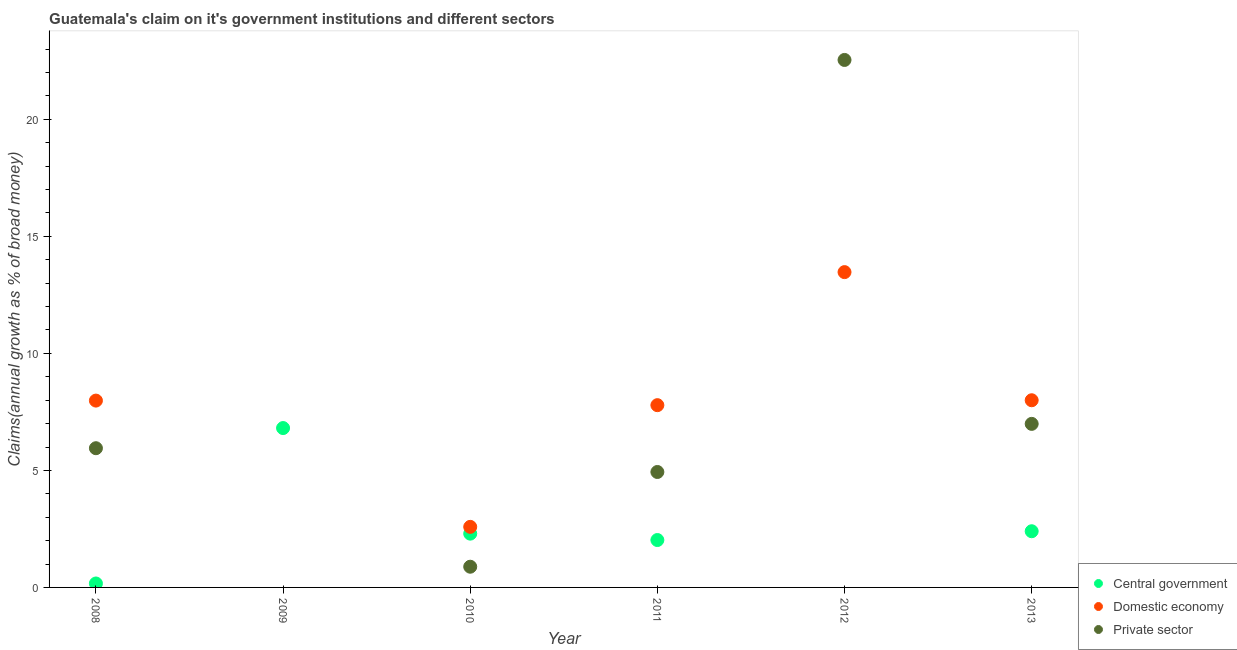Is the number of dotlines equal to the number of legend labels?
Your response must be concise. No. Across all years, what is the maximum percentage of claim on the central government?
Ensure brevity in your answer.  6.81. Across all years, what is the minimum percentage of claim on the private sector?
Make the answer very short. 0. In which year was the percentage of claim on the private sector maximum?
Your answer should be very brief. 2012. What is the total percentage of claim on the central government in the graph?
Your response must be concise. 13.7. What is the difference between the percentage of claim on the private sector in 2008 and that in 2010?
Make the answer very short. 5.06. What is the difference between the percentage of claim on the private sector in 2012 and the percentage of claim on the central government in 2009?
Keep it short and to the point. 15.73. What is the average percentage of claim on the private sector per year?
Ensure brevity in your answer.  6.88. In the year 2010, what is the difference between the percentage of claim on the central government and percentage of claim on the domestic economy?
Keep it short and to the point. -0.29. What is the ratio of the percentage of claim on the private sector in 2010 to that in 2011?
Give a very brief answer. 0.18. What is the difference between the highest and the second highest percentage of claim on the private sector?
Offer a very short reply. 15.55. What is the difference between the highest and the lowest percentage of claim on the domestic economy?
Offer a terse response. 13.47. Is the percentage of claim on the private sector strictly greater than the percentage of claim on the central government over the years?
Your answer should be compact. No. How many dotlines are there?
Provide a short and direct response. 3. How many years are there in the graph?
Offer a terse response. 6. What is the difference between two consecutive major ticks on the Y-axis?
Provide a succinct answer. 5. Are the values on the major ticks of Y-axis written in scientific E-notation?
Your answer should be compact. No. Where does the legend appear in the graph?
Give a very brief answer. Bottom right. How are the legend labels stacked?
Make the answer very short. Vertical. What is the title of the graph?
Keep it short and to the point. Guatemala's claim on it's government institutions and different sectors. What is the label or title of the Y-axis?
Provide a succinct answer. Claims(annual growth as % of broad money). What is the Claims(annual growth as % of broad money) in Central government in 2008?
Your answer should be compact. 0.17. What is the Claims(annual growth as % of broad money) in Domestic economy in 2008?
Provide a short and direct response. 7.98. What is the Claims(annual growth as % of broad money) of Private sector in 2008?
Give a very brief answer. 5.95. What is the Claims(annual growth as % of broad money) in Central government in 2009?
Your response must be concise. 6.81. What is the Claims(annual growth as % of broad money) of Domestic economy in 2009?
Your answer should be compact. 0. What is the Claims(annual growth as % of broad money) in Central government in 2010?
Your answer should be very brief. 2.3. What is the Claims(annual growth as % of broad money) of Domestic economy in 2010?
Keep it short and to the point. 2.59. What is the Claims(annual growth as % of broad money) in Private sector in 2010?
Your answer should be very brief. 0.88. What is the Claims(annual growth as % of broad money) of Central government in 2011?
Your response must be concise. 2.03. What is the Claims(annual growth as % of broad money) of Domestic economy in 2011?
Ensure brevity in your answer.  7.79. What is the Claims(annual growth as % of broad money) in Private sector in 2011?
Provide a succinct answer. 4.93. What is the Claims(annual growth as % of broad money) of Domestic economy in 2012?
Give a very brief answer. 13.47. What is the Claims(annual growth as % of broad money) in Private sector in 2012?
Your response must be concise. 22.54. What is the Claims(annual growth as % of broad money) in Central government in 2013?
Keep it short and to the point. 2.4. What is the Claims(annual growth as % of broad money) of Domestic economy in 2013?
Offer a very short reply. 8. What is the Claims(annual growth as % of broad money) of Private sector in 2013?
Your response must be concise. 6.99. Across all years, what is the maximum Claims(annual growth as % of broad money) in Central government?
Offer a very short reply. 6.81. Across all years, what is the maximum Claims(annual growth as % of broad money) of Domestic economy?
Ensure brevity in your answer.  13.47. Across all years, what is the maximum Claims(annual growth as % of broad money) in Private sector?
Your answer should be compact. 22.54. Across all years, what is the minimum Claims(annual growth as % of broad money) in Domestic economy?
Keep it short and to the point. 0. Across all years, what is the minimum Claims(annual growth as % of broad money) of Private sector?
Ensure brevity in your answer.  0. What is the total Claims(annual growth as % of broad money) of Central government in the graph?
Offer a very short reply. 13.7. What is the total Claims(annual growth as % of broad money) of Domestic economy in the graph?
Your answer should be compact. 39.83. What is the total Claims(annual growth as % of broad money) of Private sector in the graph?
Your answer should be very brief. 41.29. What is the difference between the Claims(annual growth as % of broad money) of Central government in 2008 and that in 2009?
Offer a terse response. -6.64. What is the difference between the Claims(annual growth as % of broad money) of Central government in 2008 and that in 2010?
Offer a very short reply. -2.13. What is the difference between the Claims(annual growth as % of broad money) in Domestic economy in 2008 and that in 2010?
Your answer should be compact. 5.39. What is the difference between the Claims(annual growth as % of broad money) of Private sector in 2008 and that in 2010?
Your answer should be compact. 5.06. What is the difference between the Claims(annual growth as % of broad money) of Central government in 2008 and that in 2011?
Offer a terse response. -1.86. What is the difference between the Claims(annual growth as % of broad money) in Domestic economy in 2008 and that in 2011?
Make the answer very short. 0.2. What is the difference between the Claims(annual growth as % of broad money) in Private sector in 2008 and that in 2011?
Offer a terse response. 1.02. What is the difference between the Claims(annual growth as % of broad money) of Domestic economy in 2008 and that in 2012?
Keep it short and to the point. -5.49. What is the difference between the Claims(annual growth as % of broad money) of Private sector in 2008 and that in 2012?
Your answer should be compact. -16.59. What is the difference between the Claims(annual growth as % of broad money) in Central government in 2008 and that in 2013?
Offer a terse response. -2.23. What is the difference between the Claims(annual growth as % of broad money) in Domestic economy in 2008 and that in 2013?
Your answer should be compact. -0.01. What is the difference between the Claims(annual growth as % of broad money) of Private sector in 2008 and that in 2013?
Make the answer very short. -1.04. What is the difference between the Claims(annual growth as % of broad money) of Central government in 2009 and that in 2010?
Ensure brevity in your answer.  4.51. What is the difference between the Claims(annual growth as % of broad money) of Central government in 2009 and that in 2011?
Provide a short and direct response. 4.78. What is the difference between the Claims(annual growth as % of broad money) of Central government in 2009 and that in 2013?
Ensure brevity in your answer.  4.41. What is the difference between the Claims(annual growth as % of broad money) of Central government in 2010 and that in 2011?
Your answer should be very brief. 0.27. What is the difference between the Claims(annual growth as % of broad money) in Domestic economy in 2010 and that in 2011?
Make the answer very short. -5.2. What is the difference between the Claims(annual growth as % of broad money) in Private sector in 2010 and that in 2011?
Give a very brief answer. -4.05. What is the difference between the Claims(annual growth as % of broad money) of Domestic economy in 2010 and that in 2012?
Ensure brevity in your answer.  -10.88. What is the difference between the Claims(annual growth as % of broad money) in Private sector in 2010 and that in 2012?
Give a very brief answer. -21.65. What is the difference between the Claims(annual growth as % of broad money) of Central government in 2010 and that in 2013?
Provide a succinct answer. -0.1. What is the difference between the Claims(annual growth as % of broad money) of Domestic economy in 2010 and that in 2013?
Provide a short and direct response. -5.41. What is the difference between the Claims(annual growth as % of broad money) in Private sector in 2010 and that in 2013?
Your response must be concise. -6.1. What is the difference between the Claims(annual growth as % of broad money) in Domestic economy in 2011 and that in 2012?
Your answer should be very brief. -5.68. What is the difference between the Claims(annual growth as % of broad money) of Private sector in 2011 and that in 2012?
Your answer should be compact. -17.61. What is the difference between the Claims(annual growth as % of broad money) in Central government in 2011 and that in 2013?
Provide a short and direct response. -0.38. What is the difference between the Claims(annual growth as % of broad money) of Domestic economy in 2011 and that in 2013?
Keep it short and to the point. -0.21. What is the difference between the Claims(annual growth as % of broad money) of Private sector in 2011 and that in 2013?
Offer a very short reply. -2.06. What is the difference between the Claims(annual growth as % of broad money) of Domestic economy in 2012 and that in 2013?
Provide a short and direct response. 5.47. What is the difference between the Claims(annual growth as % of broad money) in Private sector in 2012 and that in 2013?
Offer a very short reply. 15.55. What is the difference between the Claims(annual growth as % of broad money) in Central government in 2008 and the Claims(annual growth as % of broad money) in Domestic economy in 2010?
Offer a very short reply. -2.42. What is the difference between the Claims(annual growth as % of broad money) in Central government in 2008 and the Claims(annual growth as % of broad money) in Private sector in 2010?
Keep it short and to the point. -0.72. What is the difference between the Claims(annual growth as % of broad money) of Domestic economy in 2008 and the Claims(annual growth as % of broad money) of Private sector in 2010?
Offer a very short reply. 7.1. What is the difference between the Claims(annual growth as % of broad money) of Central government in 2008 and the Claims(annual growth as % of broad money) of Domestic economy in 2011?
Your response must be concise. -7.62. What is the difference between the Claims(annual growth as % of broad money) of Central government in 2008 and the Claims(annual growth as % of broad money) of Private sector in 2011?
Your answer should be compact. -4.76. What is the difference between the Claims(annual growth as % of broad money) of Domestic economy in 2008 and the Claims(annual growth as % of broad money) of Private sector in 2011?
Make the answer very short. 3.05. What is the difference between the Claims(annual growth as % of broad money) of Central government in 2008 and the Claims(annual growth as % of broad money) of Domestic economy in 2012?
Your answer should be compact. -13.3. What is the difference between the Claims(annual growth as % of broad money) in Central government in 2008 and the Claims(annual growth as % of broad money) in Private sector in 2012?
Your answer should be compact. -22.37. What is the difference between the Claims(annual growth as % of broad money) of Domestic economy in 2008 and the Claims(annual growth as % of broad money) of Private sector in 2012?
Your answer should be compact. -14.55. What is the difference between the Claims(annual growth as % of broad money) in Central government in 2008 and the Claims(annual growth as % of broad money) in Domestic economy in 2013?
Your answer should be compact. -7.83. What is the difference between the Claims(annual growth as % of broad money) in Central government in 2008 and the Claims(annual growth as % of broad money) in Private sector in 2013?
Your answer should be very brief. -6.82. What is the difference between the Claims(annual growth as % of broad money) of Domestic economy in 2008 and the Claims(annual growth as % of broad money) of Private sector in 2013?
Offer a very short reply. 0.99. What is the difference between the Claims(annual growth as % of broad money) in Central government in 2009 and the Claims(annual growth as % of broad money) in Domestic economy in 2010?
Ensure brevity in your answer.  4.22. What is the difference between the Claims(annual growth as % of broad money) of Central government in 2009 and the Claims(annual growth as % of broad money) of Private sector in 2010?
Offer a very short reply. 5.92. What is the difference between the Claims(annual growth as % of broad money) in Central government in 2009 and the Claims(annual growth as % of broad money) in Domestic economy in 2011?
Your response must be concise. -0.98. What is the difference between the Claims(annual growth as % of broad money) of Central government in 2009 and the Claims(annual growth as % of broad money) of Private sector in 2011?
Provide a succinct answer. 1.88. What is the difference between the Claims(annual growth as % of broad money) of Central government in 2009 and the Claims(annual growth as % of broad money) of Domestic economy in 2012?
Provide a succinct answer. -6.66. What is the difference between the Claims(annual growth as % of broad money) of Central government in 2009 and the Claims(annual growth as % of broad money) of Private sector in 2012?
Ensure brevity in your answer.  -15.73. What is the difference between the Claims(annual growth as % of broad money) in Central government in 2009 and the Claims(annual growth as % of broad money) in Domestic economy in 2013?
Provide a succinct answer. -1.19. What is the difference between the Claims(annual growth as % of broad money) of Central government in 2009 and the Claims(annual growth as % of broad money) of Private sector in 2013?
Provide a short and direct response. -0.18. What is the difference between the Claims(annual growth as % of broad money) of Central government in 2010 and the Claims(annual growth as % of broad money) of Domestic economy in 2011?
Ensure brevity in your answer.  -5.49. What is the difference between the Claims(annual growth as % of broad money) of Central government in 2010 and the Claims(annual growth as % of broad money) of Private sector in 2011?
Ensure brevity in your answer.  -2.63. What is the difference between the Claims(annual growth as % of broad money) in Domestic economy in 2010 and the Claims(annual growth as % of broad money) in Private sector in 2011?
Provide a short and direct response. -2.34. What is the difference between the Claims(annual growth as % of broad money) of Central government in 2010 and the Claims(annual growth as % of broad money) of Domestic economy in 2012?
Offer a terse response. -11.17. What is the difference between the Claims(annual growth as % of broad money) of Central government in 2010 and the Claims(annual growth as % of broad money) of Private sector in 2012?
Give a very brief answer. -20.24. What is the difference between the Claims(annual growth as % of broad money) in Domestic economy in 2010 and the Claims(annual growth as % of broad money) in Private sector in 2012?
Your answer should be compact. -19.95. What is the difference between the Claims(annual growth as % of broad money) in Central government in 2010 and the Claims(annual growth as % of broad money) in Domestic economy in 2013?
Make the answer very short. -5.7. What is the difference between the Claims(annual growth as % of broad money) of Central government in 2010 and the Claims(annual growth as % of broad money) of Private sector in 2013?
Make the answer very short. -4.69. What is the difference between the Claims(annual growth as % of broad money) of Domestic economy in 2010 and the Claims(annual growth as % of broad money) of Private sector in 2013?
Your answer should be compact. -4.4. What is the difference between the Claims(annual growth as % of broad money) in Central government in 2011 and the Claims(annual growth as % of broad money) in Domestic economy in 2012?
Your response must be concise. -11.45. What is the difference between the Claims(annual growth as % of broad money) in Central government in 2011 and the Claims(annual growth as % of broad money) in Private sector in 2012?
Offer a very short reply. -20.51. What is the difference between the Claims(annual growth as % of broad money) in Domestic economy in 2011 and the Claims(annual growth as % of broad money) in Private sector in 2012?
Offer a very short reply. -14.75. What is the difference between the Claims(annual growth as % of broad money) in Central government in 2011 and the Claims(annual growth as % of broad money) in Domestic economy in 2013?
Your answer should be very brief. -5.97. What is the difference between the Claims(annual growth as % of broad money) in Central government in 2011 and the Claims(annual growth as % of broad money) in Private sector in 2013?
Keep it short and to the point. -4.96. What is the difference between the Claims(annual growth as % of broad money) in Domestic economy in 2011 and the Claims(annual growth as % of broad money) in Private sector in 2013?
Offer a very short reply. 0.8. What is the difference between the Claims(annual growth as % of broad money) in Domestic economy in 2012 and the Claims(annual growth as % of broad money) in Private sector in 2013?
Keep it short and to the point. 6.48. What is the average Claims(annual growth as % of broad money) in Central government per year?
Your response must be concise. 2.28. What is the average Claims(annual growth as % of broad money) of Domestic economy per year?
Keep it short and to the point. 6.64. What is the average Claims(annual growth as % of broad money) in Private sector per year?
Your answer should be compact. 6.88. In the year 2008, what is the difference between the Claims(annual growth as % of broad money) in Central government and Claims(annual growth as % of broad money) in Domestic economy?
Your answer should be compact. -7.81. In the year 2008, what is the difference between the Claims(annual growth as % of broad money) of Central government and Claims(annual growth as % of broad money) of Private sector?
Give a very brief answer. -5.78. In the year 2008, what is the difference between the Claims(annual growth as % of broad money) in Domestic economy and Claims(annual growth as % of broad money) in Private sector?
Provide a short and direct response. 2.03. In the year 2010, what is the difference between the Claims(annual growth as % of broad money) in Central government and Claims(annual growth as % of broad money) in Domestic economy?
Provide a succinct answer. -0.29. In the year 2010, what is the difference between the Claims(annual growth as % of broad money) of Central government and Claims(annual growth as % of broad money) of Private sector?
Provide a succinct answer. 1.41. In the year 2010, what is the difference between the Claims(annual growth as % of broad money) of Domestic economy and Claims(annual growth as % of broad money) of Private sector?
Keep it short and to the point. 1.7. In the year 2011, what is the difference between the Claims(annual growth as % of broad money) of Central government and Claims(annual growth as % of broad money) of Domestic economy?
Keep it short and to the point. -5.76. In the year 2011, what is the difference between the Claims(annual growth as % of broad money) of Central government and Claims(annual growth as % of broad money) of Private sector?
Make the answer very short. -2.91. In the year 2011, what is the difference between the Claims(annual growth as % of broad money) in Domestic economy and Claims(annual growth as % of broad money) in Private sector?
Give a very brief answer. 2.86. In the year 2012, what is the difference between the Claims(annual growth as % of broad money) of Domestic economy and Claims(annual growth as % of broad money) of Private sector?
Ensure brevity in your answer.  -9.07. In the year 2013, what is the difference between the Claims(annual growth as % of broad money) in Central government and Claims(annual growth as % of broad money) in Domestic economy?
Ensure brevity in your answer.  -5.6. In the year 2013, what is the difference between the Claims(annual growth as % of broad money) of Central government and Claims(annual growth as % of broad money) of Private sector?
Your response must be concise. -4.59. In the year 2013, what is the difference between the Claims(annual growth as % of broad money) in Domestic economy and Claims(annual growth as % of broad money) in Private sector?
Provide a short and direct response. 1.01. What is the ratio of the Claims(annual growth as % of broad money) in Central government in 2008 to that in 2009?
Your answer should be compact. 0.02. What is the ratio of the Claims(annual growth as % of broad money) of Central government in 2008 to that in 2010?
Offer a terse response. 0.07. What is the ratio of the Claims(annual growth as % of broad money) in Domestic economy in 2008 to that in 2010?
Offer a very short reply. 3.08. What is the ratio of the Claims(annual growth as % of broad money) in Private sector in 2008 to that in 2010?
Provide a short and direct response. 6.72. What is the ratio of the Claims(annual growth as % of broad money) in Central government in 2008 to that in 2011?
Ensure brevity in your answer.  0.08. What is the ratio of the Claims(annual growth as % of broad money) of Private sector in 2008 to that in 2011?
Provide a short and direct response. 1.21. What is the ratio of the Claims(annual growth as % of broad money) of Domestic economy in 2008 to that in 2012?
Your response must be concise. 0.59. What is the ratio of the Claims(annual growth as % of broad money) of Private sector in 2008 to that in 2012?
Ensure brevity in your answer.  0.26. What is the ratio of the Claims(annual growth as % of broad money) of Central government in 2008 to that in 2013?
Your answer should be compact. 0.07. What is the ratio of the Claims(annual growth as % of broad money) of Domestic economy in 2008 to that in 2013?
Provide a succinct answer. 1. What is the ratio of the Claims(annual growth as % of broad money) of Private sector in 2008 to that in 2013?
Provide a succinct answer. 0.85. What is the ratio of the Claims(annual growth as % of broad money) of Central government in 2009 to that in 2010?
Your response must be concise. 2.96. What is the ratio of the Claims(annual growth as % of broad money) of Central government in 2009 to that in 2011?
Offer a very short reply. 3.36. What is the ratio of the Claims(annual growth as % of broad money) of Central government in 2009 to that in 2013?
Give a very brief answer. 2.84. What is the ratio of the Claims(annual growth as % of broad money) in Central government in 2010 to that in 2011?
Your answer should be compact. 1.13. What is the ratio of the Claims(annual growth as % of broad money) in Domestic economy in 2010 to that in 2011?
Give a very brief answer. 0.33. What is the ratio of the Claims(annual growth as % of broad money) in Private sector in 2010 to that in 2011?
Keep it short and to the point. 0.18. What is the ratio of the Claims(annual growth as % of broad money) of Domestic economy in 2010 to that in 2012?
Offer a terse response. 0.19. What is the ratio of the Claims(annual growth as % of broad money) of Private sector in 2010 to that in 2012?
Give a very brief answer. 0.04. What is the ratio of the Claims(annual growth as % of broad money) of Central government in 2010 to that in 2013?
Offer a terse response. 0.96. What is the ratio of the Claims(annual growth as % of broad money) of Domestic economy in 2010 to that in 2013?
Offer a very short reply. 0.32. What is the ratio of the Claims(annual growth as % of broad money) in Private sector in 2010 to that in 2013?
Offer a very short reply. 0.13. What is the ratio of the Claims(annual growth as % of broad money) of Domestic economy in 2011 to that in 2012?
Provide a succinct answer. 0.58. What is the ratio of the Claims(annual growth as % of broad money) of Private sector in 2011 to that in 2012?
Keep it short and to the point. 0.22. What is the ratio of the Claims(annual growth as % of broad money) in Central government in 2011 to that in 2013?
Your answer should be compact. 0.84. What is the ratio of the Claims(annual growth as % of broad money) of Domestic economy in 2011 to that in 2013?
Your answer should be compact. 0.97. What is the ratio of the Claims(annual growth as % of broad money) in Private sector in 2011 to that in 2013?
Ensure brevity in your answer.  0.71. What is the ratio of the Claims(annual growth as % of broad money) of Domestic economy in 2012 to that in 2013?
Offer a very short reply. 1.68. What is the ratio of the Claims(annual growth as % of broad money) in Private sector in 2012 to that in 2013?
Offer a terse response. 3.23. What is the difference between the highest and the second highest Claims(annual growth as % of broad money) in Central government?
Make the answer very short. 4.41. What is the difference between the highest and the second highest Claims(annual growth as % of broad money) in Domestic economy?
Make the answer very short. 5.47. What is the difference between the highest and the second highest Claims(annual growth as % of broad money) of Private sector?
Ensure brevity in your answer.  15.55. What is the difference between the highest and the lowest Claims(annual growth as % of broad money) of Central government?
Keep it short and to the point. 6.81. What is the difference between the highest and the lowest Claims(annual growth as % of broad money) in Domestic economy?
Make the answer very short. 13.47. What is the difference between the highest and the lowest Claims(annual growth as % of broad money) in Private sector?
Your response must be concise. 22.54. 